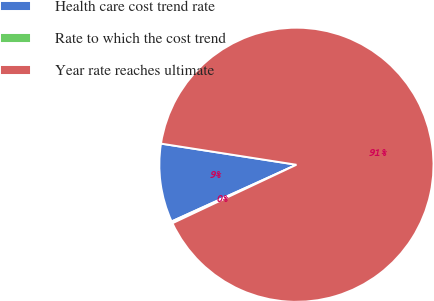Convert chart. <chart><loc_0><loc_0><loc_500><loc_500><pie_chart><fcel>Health care cost trend rate<fcel>Rate to which the cost trend<fcel>Year rate reaches ultimate<nl><fcel>9.25%<fcel>0.23%<fcel>90.52%<nl></chart> 